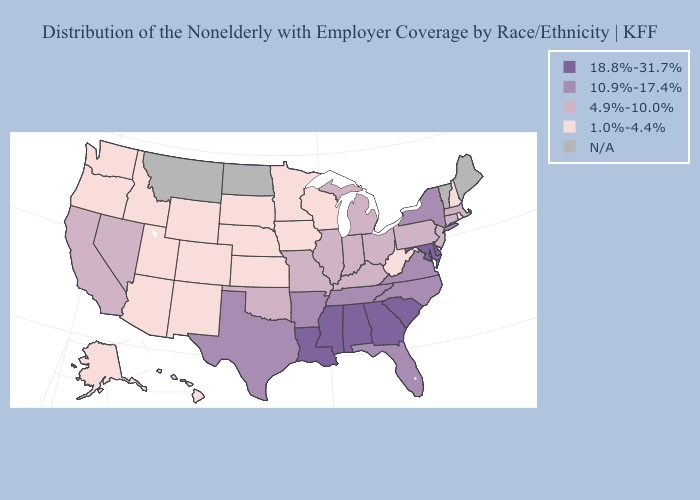Does Wisconsin have the highest value in the MidWest?
Answer briefly. No. Name the states that have a value in the range 10.9%-17.4%?
Answer briefly. Arkansas, Florida, New York, North Carolina, Tennessee, Texas, Virginia. What is the value of Arizona?
Short answer required. 1.0%-4.4%. Name the states that have a value in the range 1.0%-4.4%?
Quick response, please. Alaska, Arizona, Colorado, Hawaii, Idaho, Iowa, Kansas, Minnesota, Nebraska, New Hampshire, New Mexico, Oregon, Rhode Island, South Dakota, Utah, Washington, West Virginia, Wisconsin, Wyoming. Name the states that have a value in the range N/A?
Be succinct. Maine, Montana, North Dakota, Vermont. Which states have the lowest value in the MidWest?
Keep it brief. Iowa, Kansas, Minnesota, Nebraska, South Dakota, Wisconsin. Name the states that have a value in the range 18.8%-31.7%?
Answer briefly. Alabama, Delaware, Georgia, Louisiana, Maryland, Mississippi, South Carolina. Does the map have missing data?
Answer briefly. Yes. Does Kansas have the highest value in the MidWest?
Answer briefly. No. Does Nevada have the lowest value in the West?
Concise answer only. No. What is the value of West Virginia?
Keep it brief. 1.0%-4.4%. What is the value of Minnesota?
Concise answer only. 1.0%-4.4%. Name the states that have a value in the range 10.9%-17.4%?
Give a very brief answer. Arkansas, Florida, New York, North Carolina, Tennessee, Texas, Virginia. Name the states that have a value in the range 4.9%-10.0%?
Give a very brief answer. California, Connecticut, Illinois, Indiana, Kentucky, Massachusetts, Michigan, Missouri, Nevada, New Jersey, Ohio, Oklahoma, Pennsylvania. What is the highest value in the MidWest ?
Answer briefly. 4.9%-10.0%. 